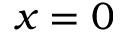<formula> <loc_0><loc_0><loc_500><loc_500>x = 0</formula> 